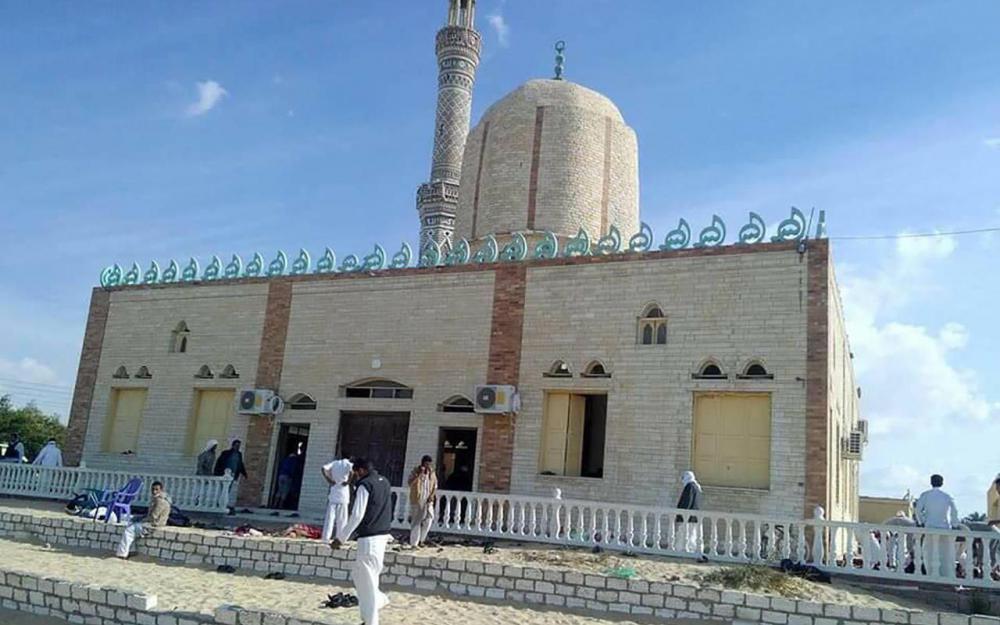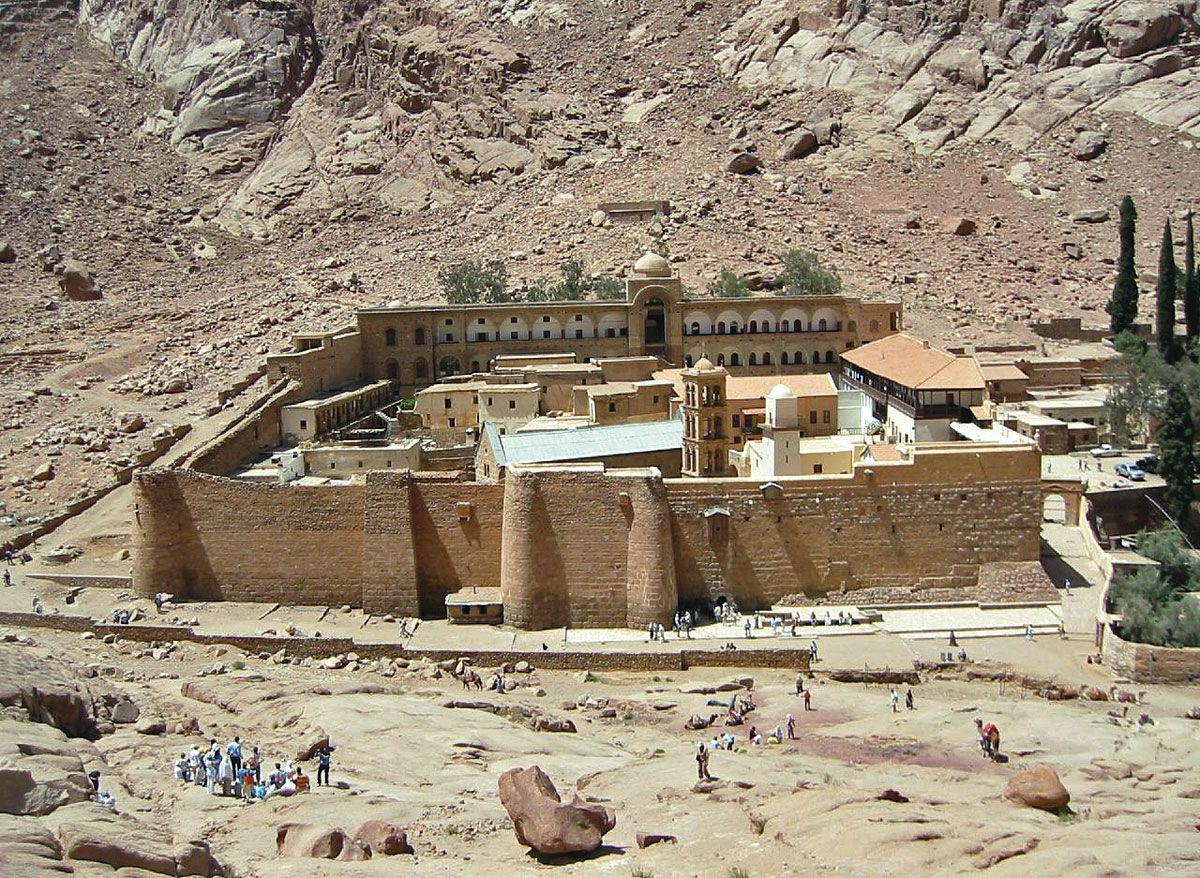The first image is the image on the left, the second image is the image on the right. For the images shown, is this caption "In at least one image there is a single castle facing forward." true? Answer yes or no. Yes. The first image is the image on the left, the second image is the image on the right. Assess this claim about the two images: "All of the boundaries are shown for one walled city in each image.". Correct or not? Answer yes or no. No. 